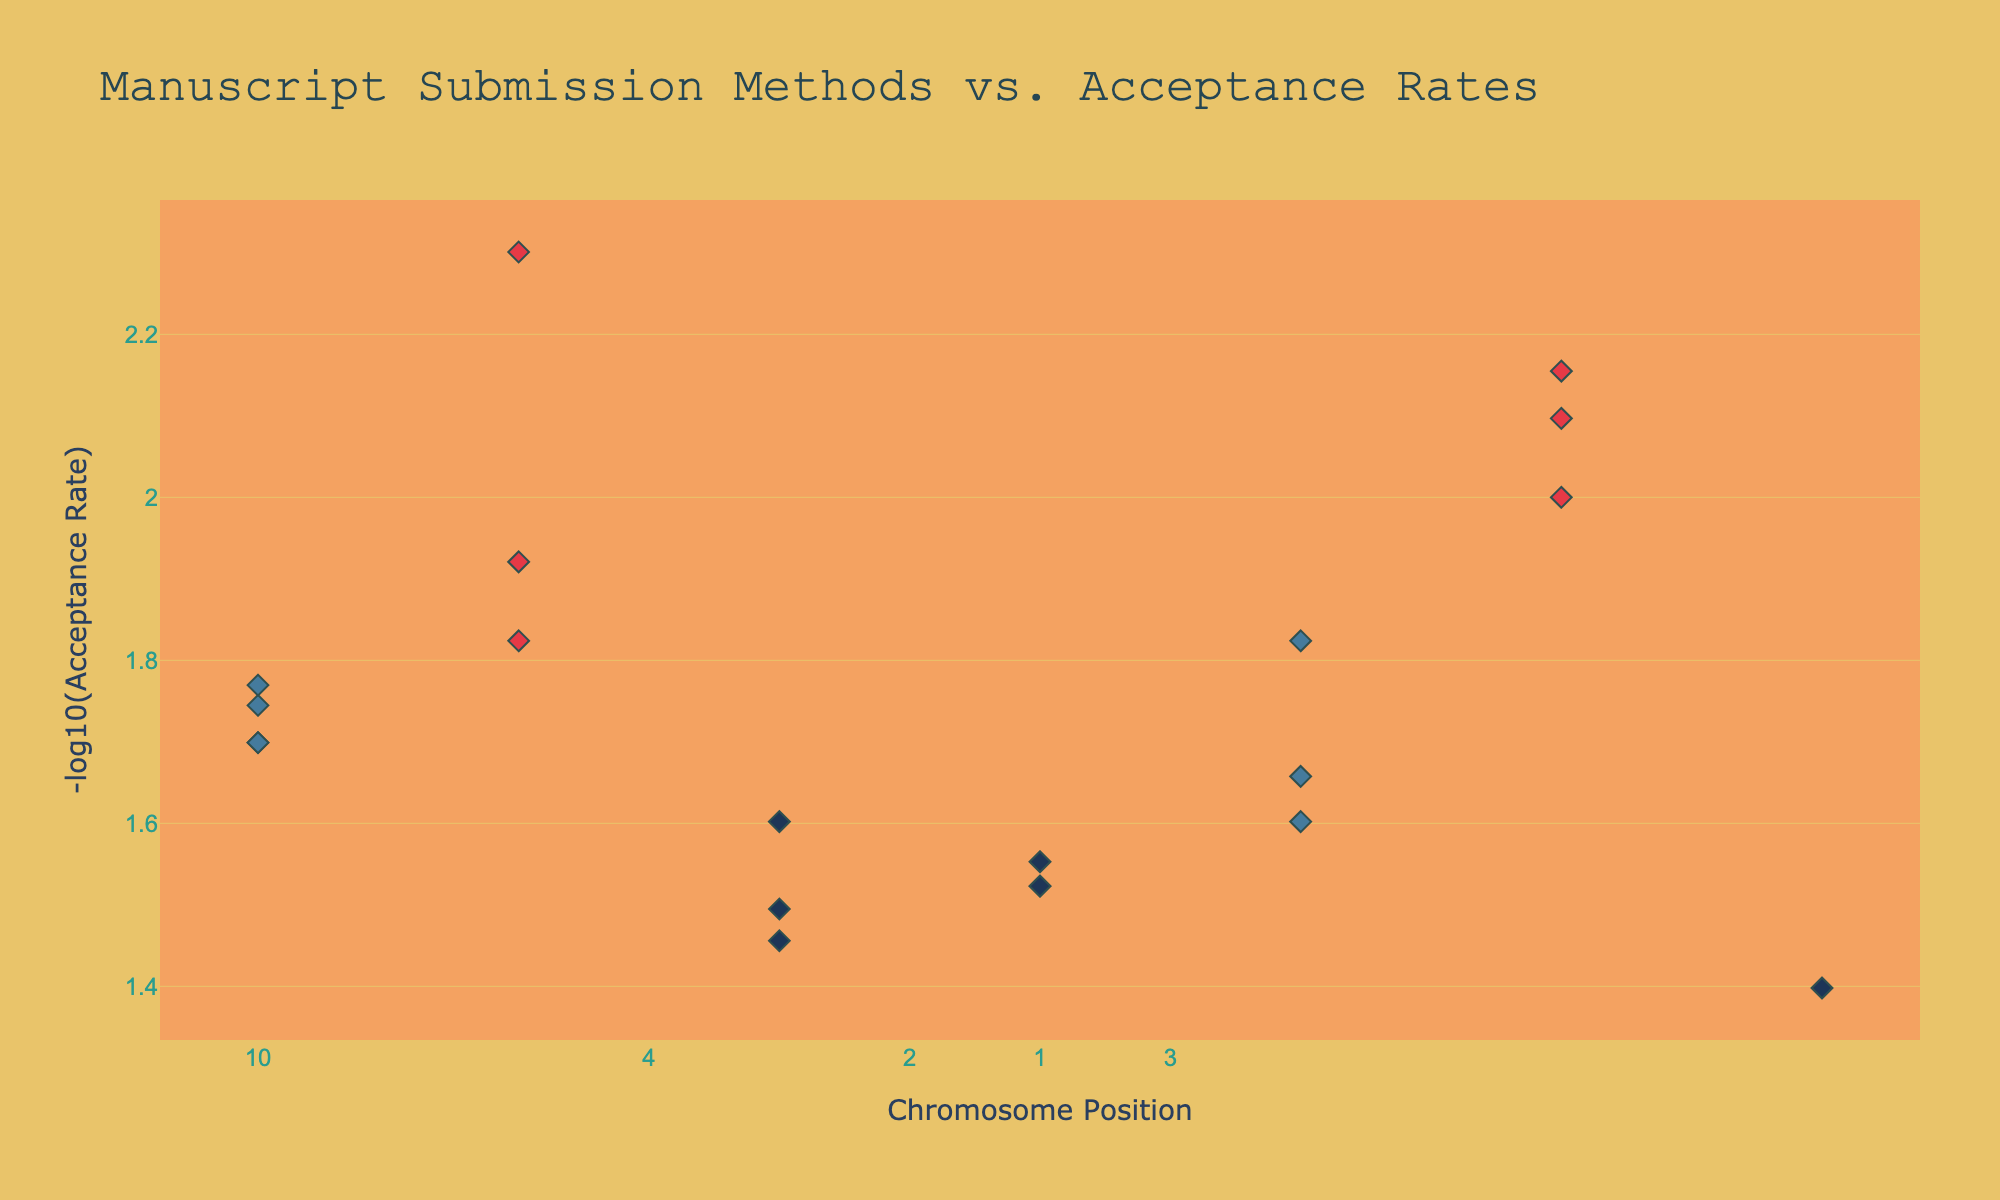What is the title of the plot? The title of the plot is typically at the top and it reads "Manuscript Submission Methods vs. Acceptance Rates".
Answer: Manuscript Submission Methods vs. Acceptance Rates Which axis represents the chromosome position? The x-axis represents the chromosome position, as indicated by the label "Chromosome Position".
Answer: x-axis How are the acceptance rates visually represented on the plot? Acceptance rates are represented using the y-axis with the title "-log10(Acceptance Rate)". This means the plot shows the negative logarithm of the acceptance rates.
Answer: -log10(Acceptance Rate) What color represents the "Online Portal" submission method in the plot? Based on the color mapping, the "Online Portal" submission method is represented by a dark blue color.
Answer: dark blue Which publishing house has the highest -log10(Acceptance Rate)? By looking at the highest point on the y-axis, we can see that Simon & Schuster has the highest -log10(Acceptance Rate).
Answer: Simon & Schuster Compare the acceptance rate of HarperCollins and Wiley. Which one is higher? HarperCollins has an acceptance rate of 0.03, and Wiley has an acceptance rate of 0.005. By comparing these numbers, HarperCollins' acceptance rate is higher.
Answer: HarperCollins How does the acceptance rate of submissions made via traditional mail compare to those made via email? To compare, we look at the general placement of data points: submissions via traditional mail generally have higher -log10 values compared to those via email, which means traditional mail generally has lower acceptance rates than email.
Answer: Email is higher What's the average -log10(Acceptance Rate) for publishing houses that accept submissions via "Traditional Mail"? Calculate -log10(0.02), -log10(0.015), -log10(0.01), -log10(0.005), -log10(0.008), -log10(0.012), and -log10(0.007), then take the average.
 (-log10(0.02) + -log10(0.015) + -log10(0.01) + -log10(0.005) + -log10(0.008) + -log10(0.012) + -log10(0.007)) / 7 ≈ (1.69897 + 1.82391 + 2 + 2.30103 + 2.09691 + 1.92082 + 2.15490) / 7 ≈ 1.999
Answer: 1.999 Which chromosome has the most diverse range of submission methods? To determine this, we look at each chromosome and count the unique submission methods. Chromosome 1 has traditional mail, email, and online portal, covering all categories.
Answer: Chromosome 1 Does the figure suggest any publishing house with a notably low acceptance rate? Looking at the high value on the y-axis, we see that Wiley has one of the lowest acceptance rates, corresponding to a high -log10(Acceptance Rate) value.
Answer: Wiley 